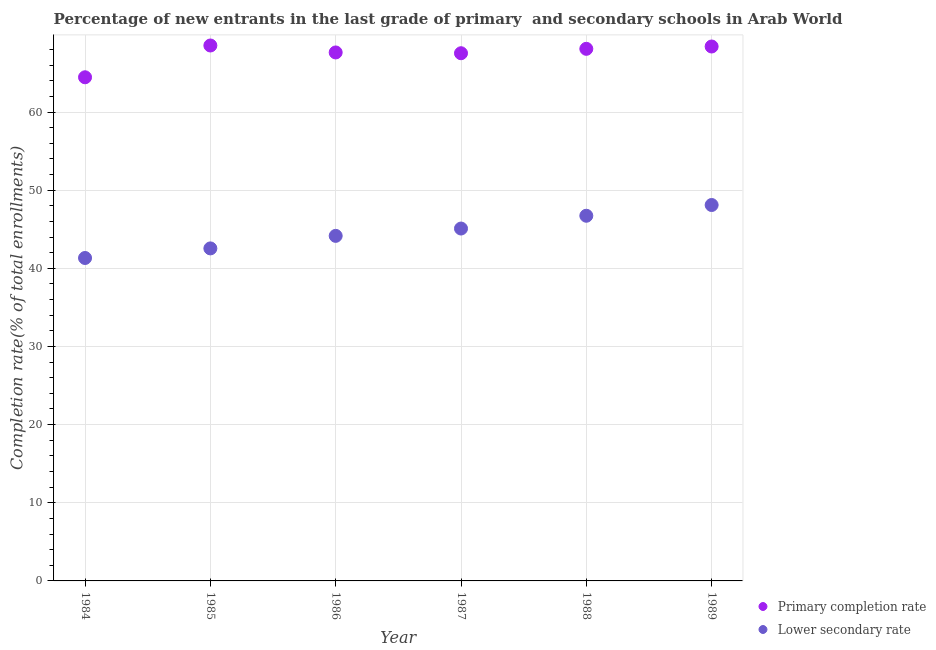What is the completion rate in primary schools in 1987?
Your answer should be compact. 67.52. Across all years, what is the maximum completion rate in secondary schools?
Give a very brief answer. 48.1. Across all years, what is the minimum completion rate in primary schools?
Ensure brevity in your answer.  64.45. In which year was the completion rate in primary schools maximum?
Ensure brevity in your answer.  1985. In which year was the completion rate in secondary schools minimum?
Offer a terse response. 1984. What is the total completion rate in primary schools in the graph?
Offer a terse response. 404.57. What is the difference between the completion rate in primary schools in 1988 and that in 1989?
Give a very brief answer. -0.3. What is the difference between the completion rate in secondary schools in 1985 and the completion rate in primary schools in 1989?
Give a very brief answer. -25.84. What is the average completion rate in primary schools per year?
Your response must be concise. 67.43. In the year 1989, what is the difference between the completion rate in primary schools and completion rate in secondary schools?
Keep it short and to the point. 20.28. In how many years, is the completion rate in secondary schools greater than 4 %?
Ensure brevity in your answer.  6. What is the ratio of the completion rate in secondary schools in 1987 to that in 1988?
Your answer should be compact. 0.96. What is the difference between the highest and the second highest completion rate in secondary schools?
Your response must be concise. 1.37. What is the difference between the highest and the lowest completion rate in primary schools?
Keep it short and to the point. 4.07. In how many years, is the completion rate in primary schools greater than the average completion rate in primary schools taken over all years?
Make the answer very short. 5. Is the completion rate in primary schools strictly greater than the completion rate in secondary schools over the years?
Provide a short and direct response. Yes. Is the completion rate in primary schools strictly less than the completion rate in secondary schools over the years?
Make the answer very short. No. What is the difference between two consecutive major ticks on the Y-axis?
Your response must be concise. 10. Does the graph contain any zero values?
Keep it short and to the point. No. Does the graph contain grids?
Your answer should be very brief. Yes. What is the title of the graph?
Provide a short and direct response. Percentage of new entrants in the last grade of primary  and secondary schools in Arab World. What is the label or title of the X-axis?
Offer a terse response. Year. What is the label or title of the Y-axis?
Ensure brevity in your answer.  Completion rate(% of total enrollments). What is the Completion rate(% of total enrollments) in Primary completion rate in 1984?
Your answer should be compact. 64.45. What is the Completion rate(% of total enrollments) in Lower secondary rate in 1984?
Offer a very short reply. 41.32. What is the Completion rate(% of total enrollments) of Primary completion rate in 1985?
Your answer should be compact. 68.51. What is the Completion rate(% of total enrollments) of Lower secondary rate in 1985?
Offer a very short reply. 42.55. What is the Completion rate(% of total enrollments) of Primary completion rate in 1986?
Give a very brief answer. 67.62. What is the Completion rate(% of total enrollments) of Lower secondary rate in 1986?
Offer a very short reply. 44.15. What is the Completion rate(% of total enrollments) in Primary completion rate in 1987?
Provide a short and direct response. 67.52. What is the Completion rate(% of total enrollments) of Lower secondary rate in 1987?
Make the answer very short. 45.09. What is the Completion rate(% of total enrollments) of Primary completion rate in 1988?
Your response must be concise. 68.09. What is the Completion rate(% of total enrollments) in Lower secondary rate in 1988?
Your response must be concise. 46.73. What is the Completion rate(% of total enrollments) in Primary completion rate in 1989?
Provide a short and direct response. 68.38. What is the Completion rate(% of total enrollments) in Lower secondary rate in 1989?
Your response must be concise. 48.1. Across all years, what is the maximum Completion rate(% of total enrollments) in Primary completion rate?
Keep it short and to the point. 68.51. Across all years, what is the maximum Completion rate(% of total enrollments) of Lower secondary rate?
Your answer should be very brief. 48.1. Across all years, what is the minimum Completion rate(% of total enrollments) in Primary completion rate?
Keep it short and to the point. 64.45. Across all years, what is the minimum Completion rate(% of total enrollments) in Lower secondary rate?
Offer a terse response. 41.32. What is the total Completion rate(% of total enrollments) of Primary completion rate in the graph?
Keep it short and to the point. 404.57. What is the total Completion rate(% of total enrollments) of Lower secondary rate in the graph?
Offer a terse response. 267.94. What is the difference between the Completion rate(% of total enrollments) of Primary completion rate in 1984 and that in 1985?
Your response must be concise. -4.07. What is the difference between the Completion rate(% of total enrollments) in Lower secondary rate in 1984 and that in 1985?
Your response must be concise. -1.23. What is the difference between the Completion rate(% of total enrollments) of Primary completion rate in 1984 and that in 1986?
Provide a succinct answer. -3.18. What is the difference between the Completion rate(% of total enrollments) of Lower secondary rate in 1984 and that in 1986?
Provide a short and direct response. -2.83. What is the difference between the Completion rate(% of total enrollments) of Primary completion rate in 1984 and that in 1987?
Your response must be concise. -3.08. What is the difference between the Completion rate(% of total enrollments) of Lower secondary rate in 1984 and that in 1987?
Provide a short and direct response. -3.77. What is the difference between the Completion rate(% of total enrollments) of Primary completion rate in 1984 and that in 1988?
Offer a very short reply. -3.64. What is the difference between the Completion rate(% of total enrollments) of Lower secondary rate in 1984 and that in 1988?
Offer a very short reply. -5.41. What is the difference between the Completion rate(% of total enrollments) of Primary completion rate in 1984 and that in 1989?
Your response must be concise. -3.94. What is the difference between the Completion rate(% of total enrollments) of Lower secondary rate in 1984 and that in 1989?
Your answer should be compact. -6.78. What is the difference between the Completion rate(% of total enrollments) in Primary completion rate in 1985 and that in 1986?
Provide a succinct answer. 0.89. What is the difference between the Completion rate(% of total enrollments) of Lower secondary rate in 1985 and that in 1986?
Offer a very short reply. -1.6. What is the difference between the Completion rate(% of total enrollments) in Primary completion rate in 1985 and that in 1987?
Provide a short and direct response. 0.99. What is the difference between the Completion rate(% of total enrollments) of Lower secondary rate in 1985 and that in 1987?
Make the answer very short. -2.54. What is the difference between the Completion rate(% of total enrollments) in Primary completion rate in 1985 and that in 1988?
Ensure brevity in your answer.  0.43. What is the difference between the Completion rate(% of total enrollments) of Lower secondary rate in 1985 and that in 1988?
Your response must be concise. -4.18. What is the difference between the Completion rate(% of total enrollments) in Primary completion rate in 1985 and that in 1989?
Provide a succinct answer. 0.13. What is the difference between the Completion rate(% of total enrollments) in Lower secondary rate in 1985 and that in 1989?
Keep it short and to the point. -5.55. What is the difference between the Completion rate(% of total enrollments) of Primary completion rate in 1986 and that in 1987?
Provide a succinct answer. 0.1. What is the difference between the Completion rate(% of total enrollments) of Lower secondary rate in 1986 and that in 1987?
Your answer should be very brief. -0.94. What is the difference between the Completion rate(% of total enrollments) of Primary completion rate in 1986 and that in 1988?
Offer a terse response. -0.46. What is the difference between the Completion rate(% of total enrollments) of Lower secondary rate in 1986 and that in 1988?
Ensure brevity in your answer.  -2.57. What is the difference between the Completion rate(% of total enrollments) of Primary completion rate in 1986 and that in 1989?
Your answer should be very brief. -0.76. What is the difference between the Completion rate(% of total enrollments) of Lower secondary rate in 1986 and that in 1989?
Offer a terse response. -3.95. What is the difference between the Completion rate(% of total enrollments) of Primary completion rate in 1987 and that in 1988?
Provide a succinct answer. -0.56. What is the difference between the Completion rate(% of total enrollments) of Lower secondary rate in 1987 and that in 1988?
Ensure brevity in your answer.  -1.64. What is the difference between the Completion rate(% of total enrollments) in Primary completion rate in 1987 and that in 1989?
Your answer should be compact. -0.86. What is the difference between the Completion rate(% of total enrollments) of Lower secondary rate in 1987 and that in 1989?
Provide a short and direct response. -3.01. What is the difference between the Completion rate(% of total enrollments) in Primary completion rate in 1988 and that in 1989?
Provide a succinct answer. -0.3. What is the difference between the Completion rate(% of total enrollments) of Lower secondary rate in 1988 and that in 1989?
Keep it short and to the point. -1.37. What is the difference between the Completion rate(% of total enrollments) in Primary completion rate in 1984 and the Completion rate(% of total enrollments) in Lower secondary rate in 1985?
Your answer should be very brief. 21.9. What is the difference between the Completion rate(% of total enrollments) in Primary completion rate in 1984 and the Completion rate(% of total enrollments) in Lower secondary rate in 1986?
Offer a very short reply. 20.29. What is the difference between the Completion rate(% of total enrollments) in Primary completion rate in 1984 and the Completion rate(% of total enrollments) in Lower secondary rate in 1987?
Your response must be concise. 19.36. What is the difference between the Completion rate(% of total enrollments) in Primary completion rate in 1984 and the Completion rate(% of total enrollments) in Lower secondary rate in 1988?
Keep it short and to the point. 17.72. What is the difference between the Completion rate(% of total enrollments) of Primary completion rate in 1984 and the Completion rate(% of total enrollments) of Lower secondary rate in 1989?
Ensure brevity in your answer.  16.34. What is the difference between the Completion rate(% of total enrollments) in Primary completion rate in 1985 and the Completion rate(% of total enrollments) in Lower secondary rate in 1986?
Offer a terse response. 24.36. What is the difference between the Completion rate(% of total enrollments) of Primary completion rate in 1985 and the Completion rate(% of total enrollments) of Lower secondary rate in 1987?
Your answer should be very brief. 23.42. What is the difference between the Completion rate(% of total enrollments) in Primary completion rate in 1985 and the Completion rate(% of total enrollments) in Lower secondary rate in 1988?
Your answer should be compact. 21.79. What is the difference between the Completion rate(% of total enrollments) of Primary completion rate in 1985 and the Completion rate(% of total enrollments) of Lower secondary rate in 1989?
Keep it short and to the point. 20.41. What is the difference between the Completion rate(% of total enrollments) in Primary completion rate in 1986 and the Completion rate(% of total enrollments) in Lower secondary rate in 1987?
Ensure brevity in your answer.  22.53. What is the difference between the Completion rate(% of total enrollments) in Primary completion rate in 1986 and the Completion rate(% of total enrollments) in Lower secondary rate in 1988?
Provide a short and direct response. 20.9. What is the difference between the Completion rate(% of total enrollments) of Primary completion rate in 1986 and the Completion rate(% of total enrollments) of Lower secondary rate in 1989?
Keep it short and to the point. 19.52. What is the difference between the Completion rate(% of total enrollments) of Primary completion rate in 1987 and the Completion rate(% of total enrollments) of Lower secondary rate in 1988?
Keep it short and to the point. 20.8. What is the difference between the Completion rate(% of total enrollments) of Primary completion rate in 1987 and the Completion rate(% of total enrollments) of Lower secondary rate in 1989?
Provide a succinct answer. 19.42. What is the difference between the Completion rate(% of total enrollments) of Primary completion rate in 1988 and the Completion rate(% of total enrollments) of Lower secondary rate in 1989?
Give a very brief answer. 19.98. What is the average Completion rate(% of total enrollments) of Primary completion rate per year?
Your answer should be compact. 67.43. What is the average Completion rate(% of total enrollments) in Lower secondary rate per year?
Give a very brief answer. 44.66. In the year 1984, what is the difference between the Completion rate(% of total enrollments) in Primary completion rate and Completion rate(% of total enrollments) in Lower secondary rate?
Your answer should be compact. 23.12. In the year 1985, what is the difference between the Completion rate(% of total enrollments) of Primary completion rate and Completion rate(% of total enrollments) of Lower secondary rate?
Your answer should be very brief. 25.96. In the year 1986, what is the difference between the Completion rate(% of total enrollments) of Primary completion rate and Completion rate(% of total enrollments) of Lower secondary rate?
Your response must be concise. 23.47. In the year 1987, what is the difference between the Completion rate(% of total enrollments) in Primary completion rate and Completion rate(% of total enrollments) in Lower secondary rate?
Provide a short and direct response. 22.43. In the year 1988, what is the difference between the Completion rate(% of total enrollments) in Primary completion rate and Completion rate(% of total enrollments) in Lower secondary rate?
Your answer should be compact. 21.36. In the year 1989, what is the difference between the Completion rate(% of total enrollments) in Primary completion rate and Completion rate(% of total enrollments) in Lower secondary rate?
Provide a succinct answer. 20.28. What is the ratio of the Completion rate(% of total enrollments) of Primary completion rate in 1984 to that in 1985?
Offer a terse response. 0.94. What is the ratio of the Completion rate(% of total enrollments) of Lower secondary rate in 1984 to that in 1985?
Offer a terse response. 0.97. What is the ratio of the Completion rate(% of total enrollments) in Primary completion rate in 1984 to that in 1986?
Keep it short and to the point. 0.95. What is the ratio of the Completion rate(% of total enrollments) of Lower secondary rate in 1984 to that in 1986?
Give a very brief answer. 0.94. What is the ratio of the Completion rate(% of total enrollments) in Primary completion rate in 1984 to that in 1987?
Give a very brief answer. 0.95. What is the ratio of the Completion rate(% of total enrollments) of Lower secondary rate in 1984 to that in 1987?
Offer a very short reply. 0.92. What is the ratio of the Completion rate(% of total enrollments) in Primary completion rate in 1984 to that in 1988?
Provide a succinct answer. 0.95. What is the ratio of the Completion rate(% of total enrollments) in Lower secondary rate in 1984 to that in 1988?
Keep it short and to the point. 0.88. What is the ratio of the Completion rate(% of total enrollments) of Primary completion rate in 1984 to that in 1989?
Ensure brevity in your answer.  0.94. What is the ratio of the Completion rate(% of total enrollments) in Lower secondary rate in 1984 to that in 1989?
Keep it short and to the point. 0.86. What is the ratio of the Completion rate(% of total enrollments) in Primary completion rate in 1985 to that in 1986?
Provide a succinct answer. 1.01. What is the ratio of the Completion rate(% of total enrollments) of Lower secondary rate in 1985 to that in 1986?
Ensure brevity in your answer.  0.96. What is the ratio of the Completion rate(% of total enrollments) in Primary completion rate in 1985 to that in 1987?
Your answer should be compact. 1.01. What is the ratio of the Completion rate(% of total enrollments) in Lower secondary rate in 1985 to that in 1987?
Provide a succinct answer. 0.94. What is the ratio of the Completion rate(% of total enrollments) of Lower secondary rate in 1985 to that in 1988?
Make the answer very short. 0.91. What is the ratio of the Completion rate(% of total enrollments) of Primary completion rate in 1985 to that in 1989?
Your response must be concise. 1. What is the ratio of the Completion rate(% of total enrollments) in Lower secondary rate in 1985 to that in 1989?
Offer a terse response. 0.88. What is the ratio of the Completion rate(% of total enrollments) of Primary completion rate in 1986 to that in 1987?
Keep it short and to the point. 1. What is the ratio of the Completion rate(% of total enrollments) in Lower secondary rate in 1986 to that in 1987?
Offer a very short reply. 0.98. What is the ratio of the Completion rate(% of total enrollments) of Lower secondary rate in 1986 to that in 1988?
Your answer should be very brief. 0.94. What is the ratio of the Completion rate(% of total enrollments) of Primary completion rate in 1986 to that in 1989?
Your answer should be compact. 0.99. What is the ratio of the Completion rate(% of total enrollments) in Lower secondary rate in 1986 to that in 1989?
Offer a terse response. 0.92. What is the ratio of the Completion rate(% of total enrollments) in Lower secondary rate in 1987 to that in 1988?
Provide a short and direct response. 0.96. What is the ratio of the Completion rate(% of total enrollments) of Primary completion rate in 1987 to that in 1989?
Your answer should be compact. 0.99. What is the ratio of the Completion rate(% of total enrollments) of Lower secondary rate in 1987 to that in 1989?
Make the answer very short. 0.94. What is the ratio of the Completion rate(% of total enrollments) in Lower secondary rate in 1988 to that in 1989?
Provide a short and direct response. 0.97. What is the difference between the highest and the second highest Completion rate(% of total enrollments) in Primary completion rate?
Ensure brevity in your answer.  0.13. What is the difference between the highest and the second highest Completion rate(% of total enrollments) in Lower secondary rate?
Your answer should be very brief. 1.37. What is the difference between the highest and the lowest Completion rate(% of total enrollments) in Primary completion rate?
Your answer should be very brief. 4.07. What is the difference between the highest and the lowest Completion rate(% of total enrollments) of Lower secondary rate?
Provide a succinct answer. 6.78. 